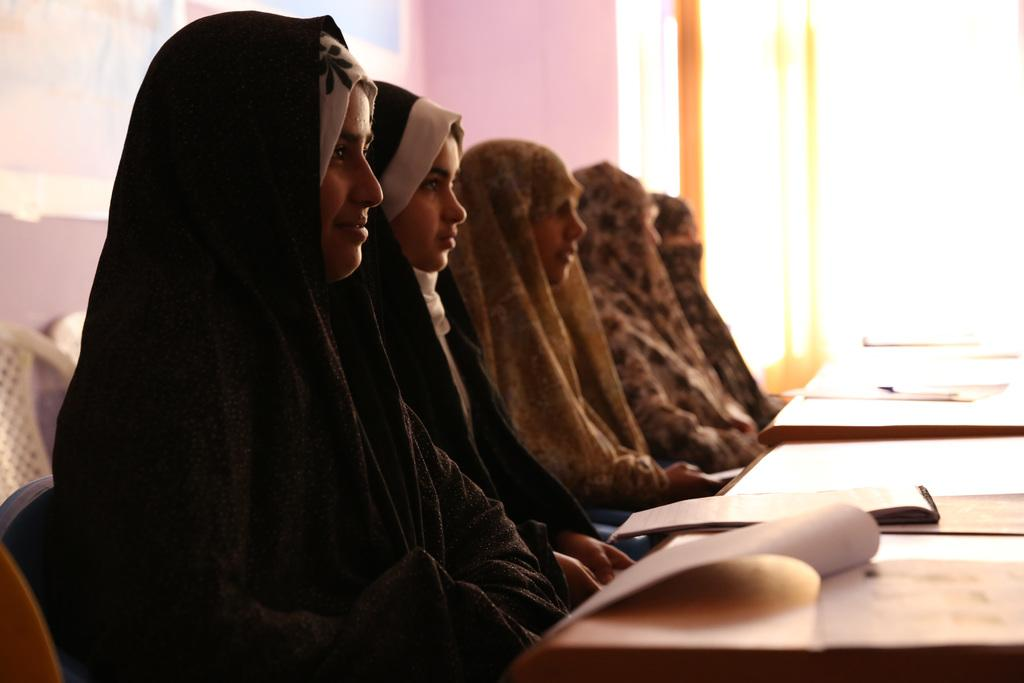What are the people in the image doing? The persons in the image are sitting on chairs. What is present on the table in the image? There is a book on the table. What is the primary object in the background of the image? There is a wall in the background of the image. What type of car is parked in front of the wall in the image? There is no car present in the image; it only features persons sitting on chairs, a table, a book, and a wall in the background. 